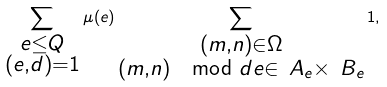Convert formula to latex. <formula><loc_0><loc_0><loc_500><loc_500>\sum _ { \substack { e \leq Q \\ ( e , d ) = 1 } } \mu ( e ) \sum _ { \substack { ( m , n ) \in \Omega \\ ( m , n ) \mod d e \in \ A _ { e } \times \ B _ { e } } } 1 ,</formula> 